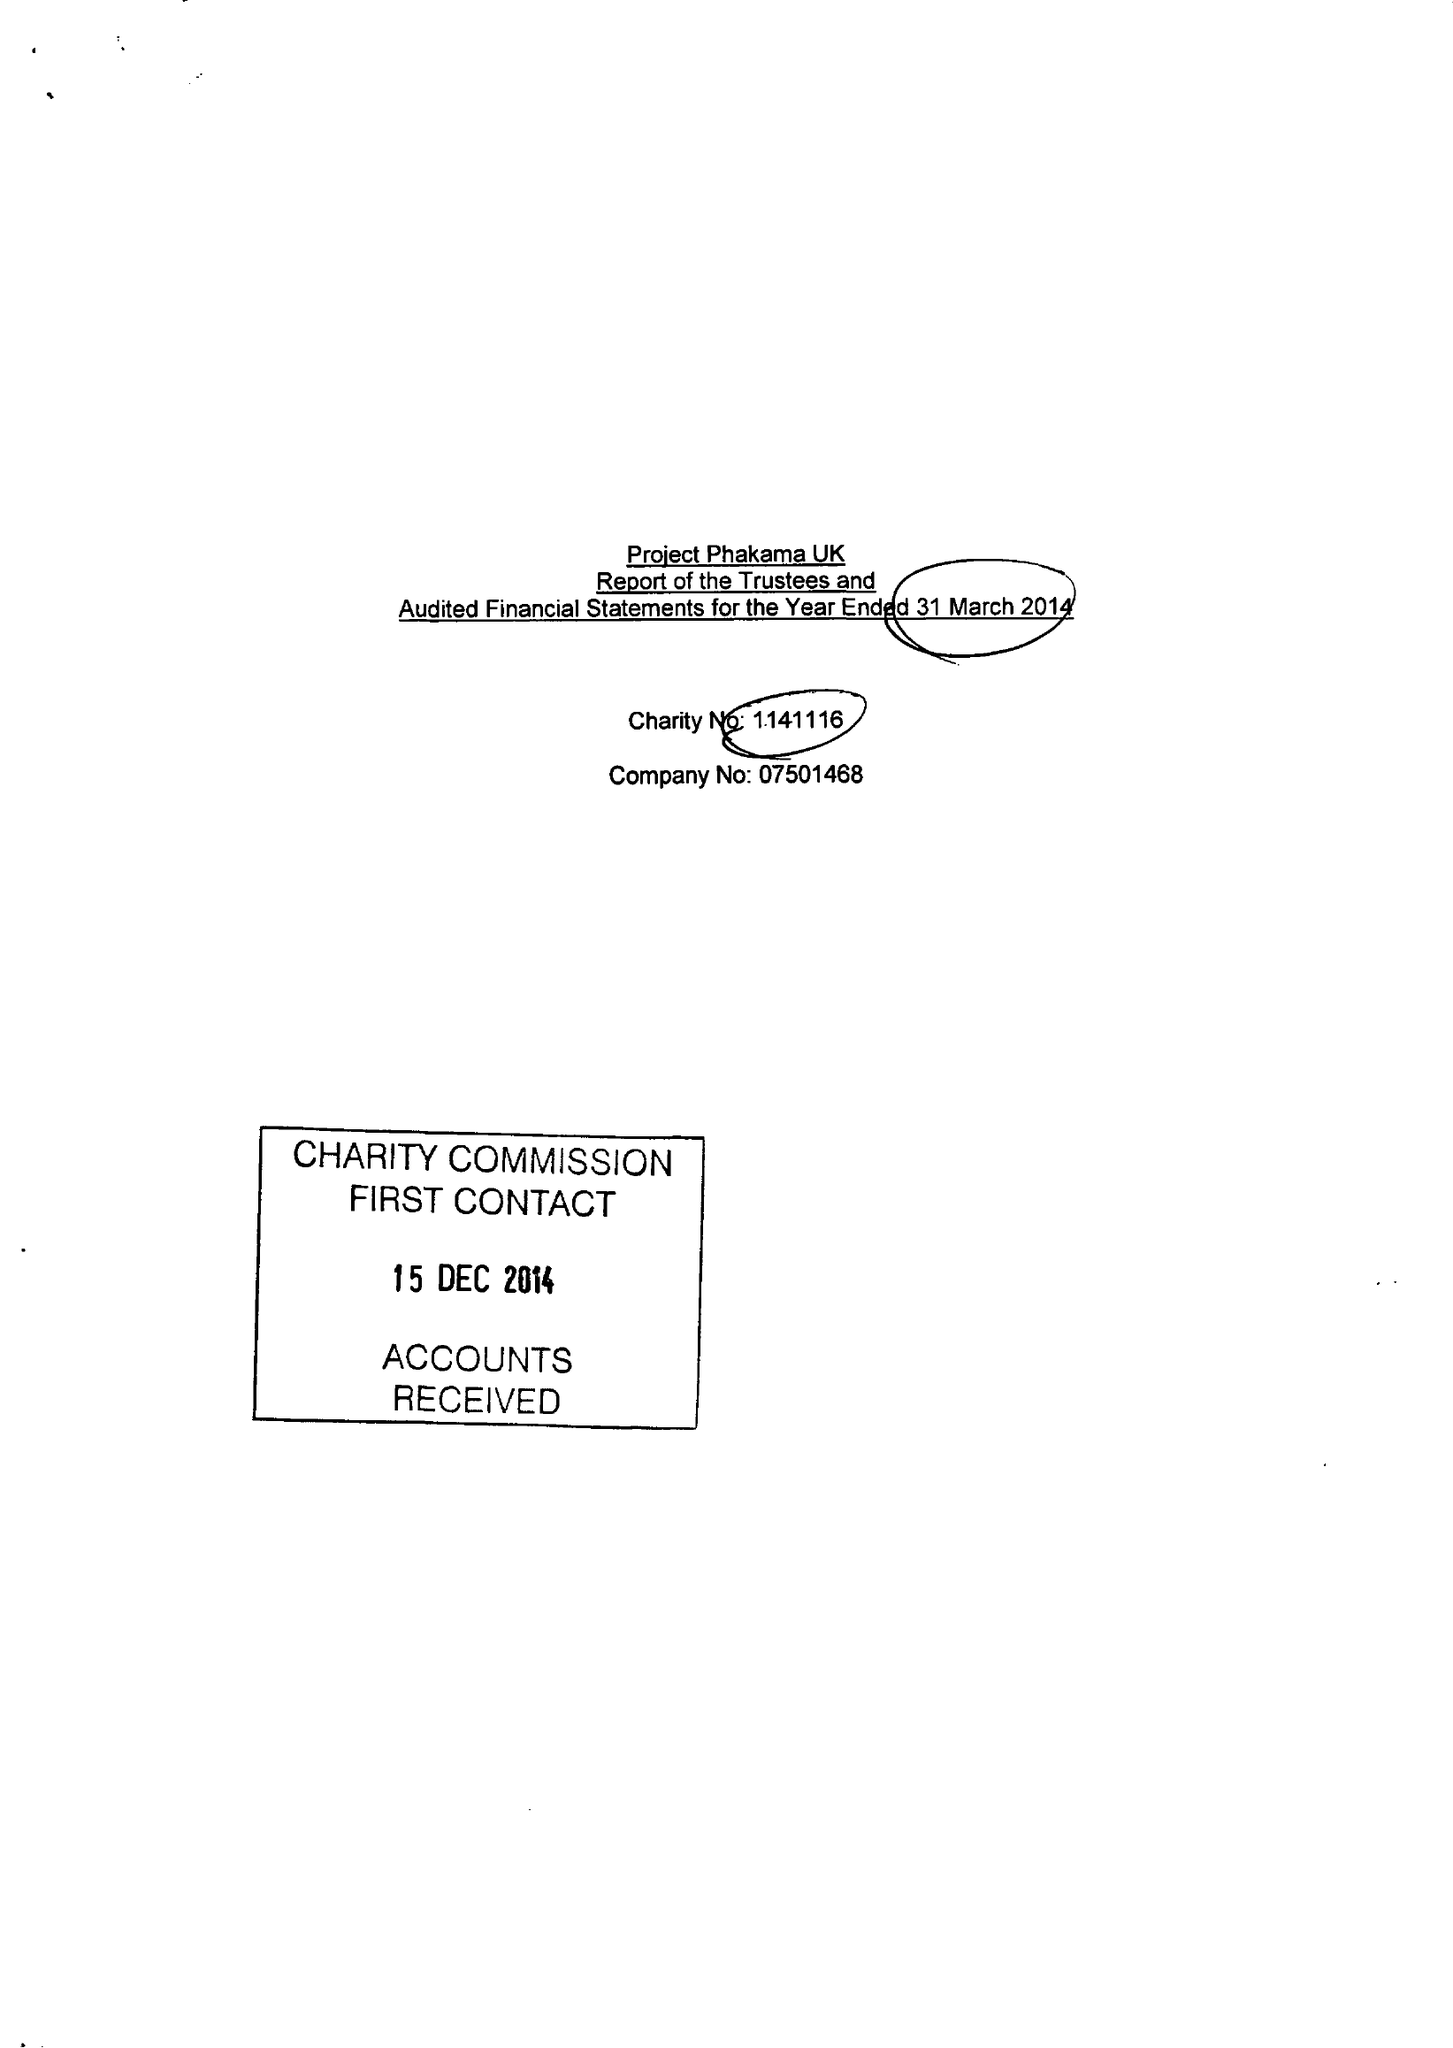What is the value for the address__post_town?
Answer the question using a single word or phrase. LONDON 